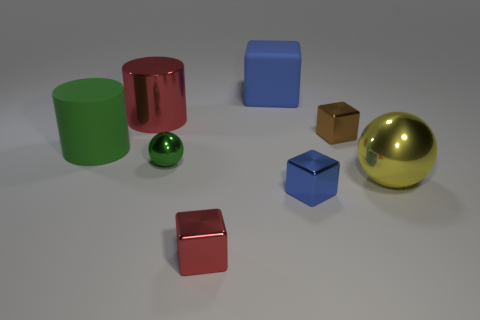Are there fewer small brown metal objects that are to the left of the red block than brown metallic cylinders?
Make the answer very short. No. Are there any big matte balls?
Offer a terse response. No. What color is the other big matte object that is the same shape as the brown object?
Provide a short and direct response. Blue. There is a small metallic thing to the left of the red metal cube; is its color the same as the big rubber cylinder?
Provide a succinct answer. Yes. Is the green matte cylinder the same size as the green metal object?
Provide a short and direct response. No. The small brown thing that is made of the same material as the green ball is what shape?
Make the answer very short. Cube. How many other objects are there of the same shape as the small brown metallic thing?
Your response must be concise. 3. The large metal object that is behind the tiny object that is right of the blue metallic block that is on the right side of the big block is what shape?
Your answer should be very brief. Cylinder. How many balls are either things or red objects?
Keep it short and to the point. 2. There is a large thing that is on the left side of the big red cylinder; is there a red object behind it?
Your response must be concise. Yes. 